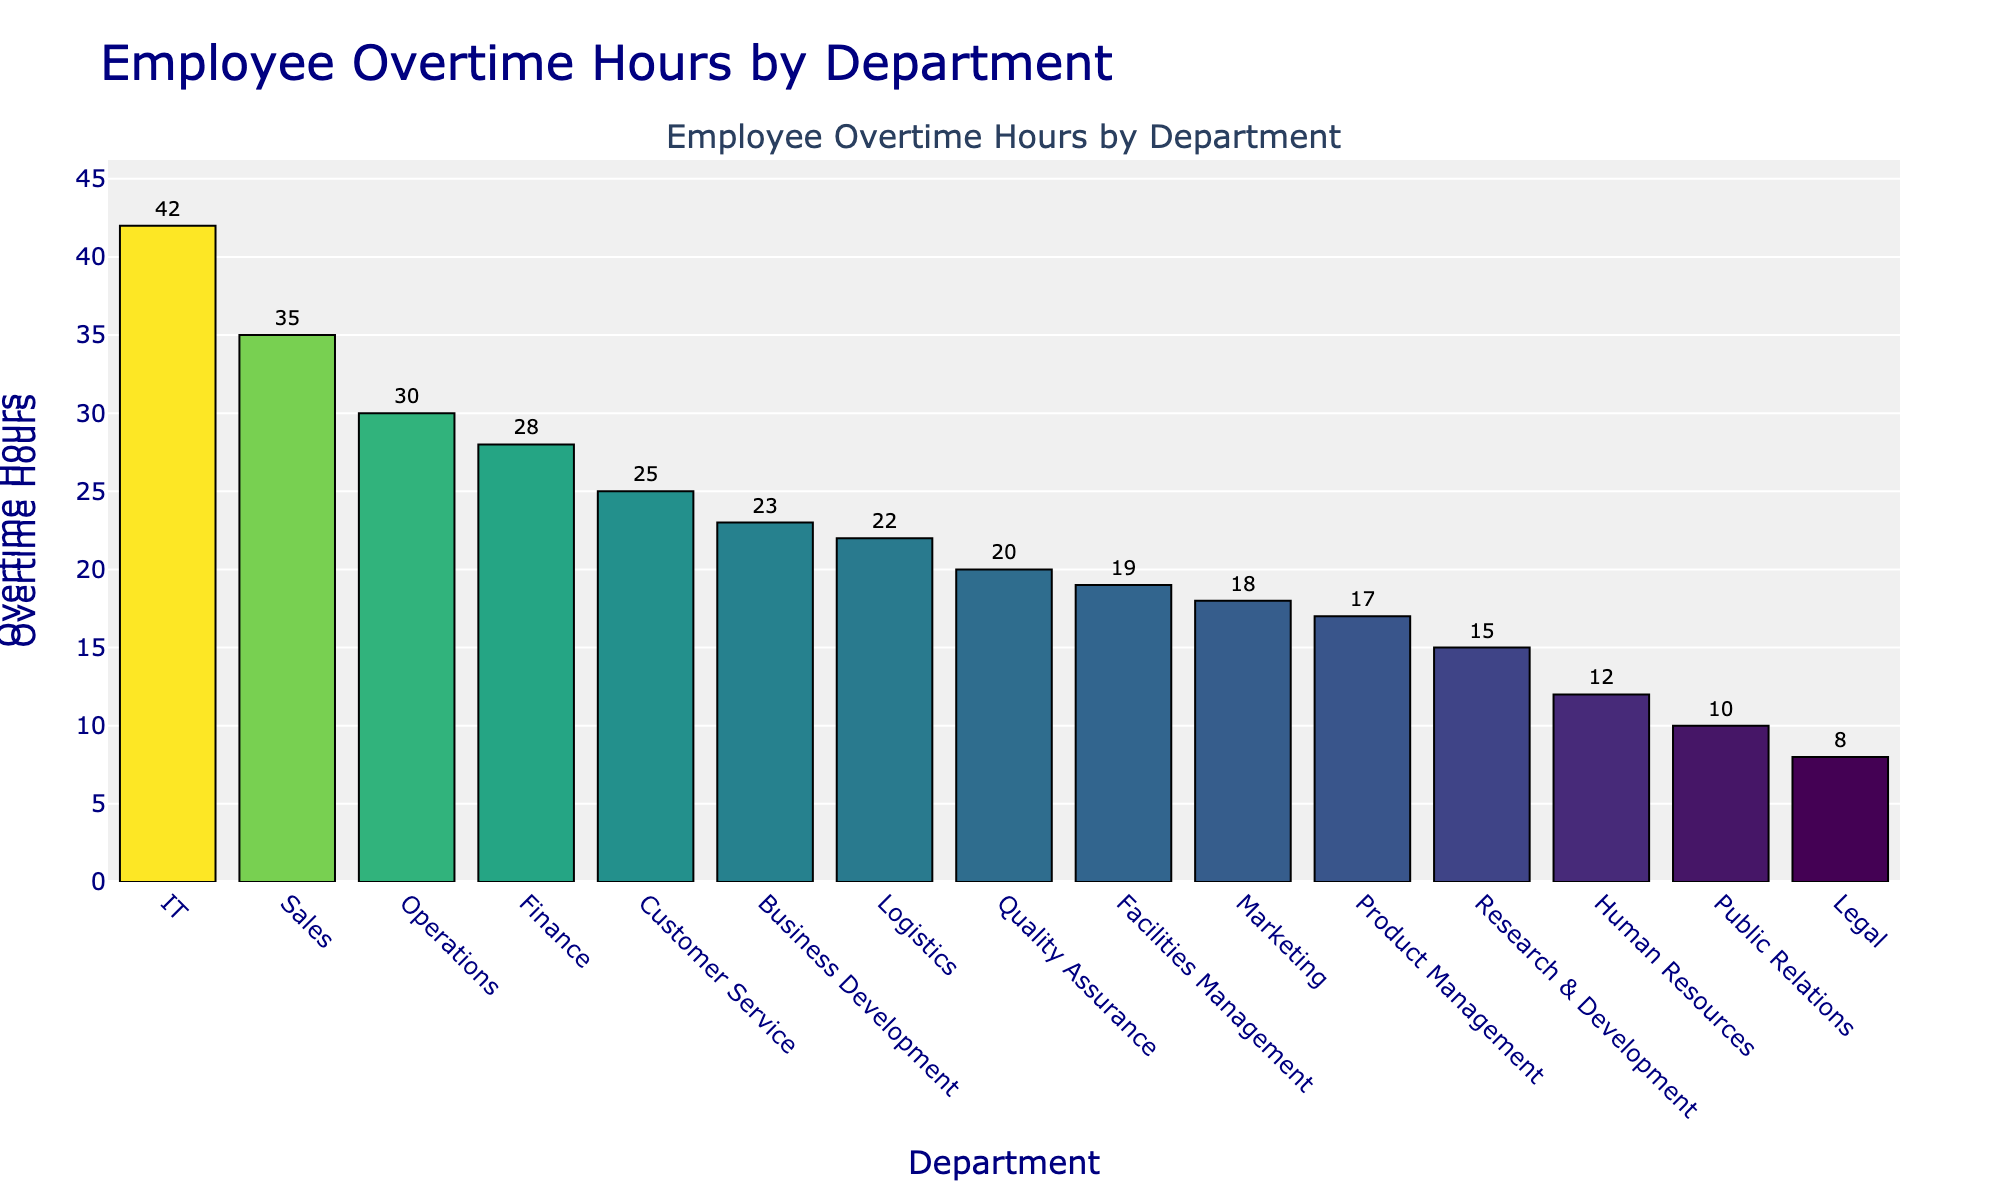What are the three departments with the highest overtime hours? First, observe and identify the departments with the tallest bars on the y-axis indicating overtime hours. The top three departments with the most overtime hours are IT, Sales, and Operations.
Answer: IT, Sales, Operations Which department has the least overtime hours? Look at the department with the shortest bar on the y-axis, indicating the lowest total of overtime hours. The department with the least overtime hours is Legal.
Answer: Legal How many more overtime hours does IT have compared to Marketing? Find the overtime hours for IT and Marketing by looking at their respective bars. IT has 42 hours, and Marketing has 18 hours. Calculate the difference: 42 - 18 = 24.
Answer: 24 What is the average overtime hours for Sales, IT, and Operations? Find the overtime hours for each: Sales (35), IT (42), and Operations (30). Sum them (35 + 42 + 30 = 107) and divide by 3 to get the average (107 / 3 ≈ 35.67).
Answer: 35.67 Which department colors are the darkest in the chart, indicating higher overtime hours? Observe the color gradient, where darker bars correspond to higher overtime hours. The departments with the darkest colors are IT (42), Sales (35), and Operations (30).
Answer: IT, Sales, Operations Compare the overtime hours between Finance and Logistics. Which one has more, and by how much? Identify the overtime hours for Finance (28) and Logistics (22) from their respective bars. Finance has more overtime hours by 6 (28 - 22).
Answer: Finance by 6 What is the total overtime hours for the Human Resources, Customer Service, and Public Relations departments combined? Sum the overtime hours for each department: Human Resources (12), Customer Service (25), Public Relations (10). The total is 12 + 25 + 10 = 47.
Answer: 47 Which departments have overtime hours falling between 15 and 25? Identify bars whose heights range from 15 to 25 hours. The departments are Marketing (18), Research & Development (15), Product Management (17), Logistics (22), Customer Service (25), Quality Assurance (20), and Facilities Management (19).
Answer: Marketing, Research & Development, Product Management, Logistics, Customer Service, Quality Assurance, Facilities Management 